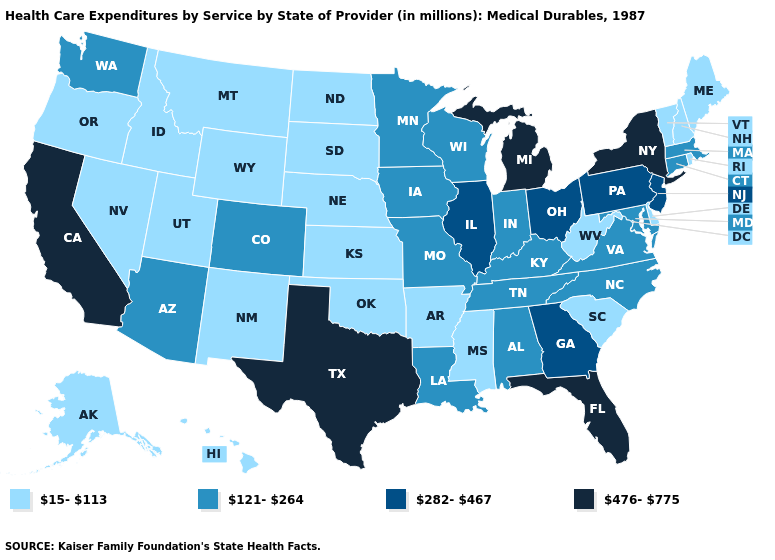Name the states that have a value in the range 121-264?
Answer briefly. Alabama, Arizona, Colorado, Connecticut, Indiana, Iowa, Kentucky, Louisiana, Maryland, Massachusetts, Minnesota, Missouri, North Carolina, Tennessee, Virginia, Washington, Wisconsin. Which states have the lowest value in the USA?
Concise answer only. Alaska, Arkansas, Delaware, Hawaii, Idaho, Kansas, Maine, Mississippi, Montana, Nebraska, Nevada, New Hampshire, New Mexico, North Dakota, Oklahoma, Oregon, Rhode Island, South Carolina, South Dakota, Utah, Vermont, West Virginia, Wyoming. Does Washington have the lowest value in the USA?
Short answer required. No. What is the value of Arkansas?
Concise answer only. 15-113. Name the states that have a value in the range 15-113?
Keep it brief. Alaska, Arkansas, Delaware, Hawaii, Idaho, Kansas, Maine, Mississippi, Montana, Nebraska, Nevada, New Hampshire, New Mexico, North Dakota, Oklahoma, Oregon, Rhode Island, South Carolina, South Dakota, Utah, Vermont, West Virginia, Wyoming. Which states have the lowest value in the South?
Keep it brief. Arkansas, Delaware, Mississippi, Oklahoma, South Carolina, West Virginia. Which states have the highest value in the USA?
Write a very short answer. California, Florida, Michigan, New York, Texas. Does the first symbol in the legend represent the smallest category?
Keep it brief. Yes. Does Maine have the lowest value in the USA?
Quick response, please. Yes. What is the value of Georgia?
Be succinct. 282-467. Name the states that have a value in the range 476-775?
Keep it brief. California, Florida, Michigan, New York, Texas. What is the highest value in the South ?
Keep it brief. 476-775. Does the first symbol in the legend represent the smallest category?
Write a very short answer. Yes. Name the states that have a value in the range 15-113?
Answer briefly. Alaska, Arkansas, Delaware, Hawaii, Idaho, Kansas, Maine, Mississippi, Montana, Nebraska, Nevada, New Hampshire, New Mexico, North Dakota, Oklahoma, Oregon, Rhode Island, South Carolina, South Dakota, Utah, Vermont, West Virginia, Wyoming. 